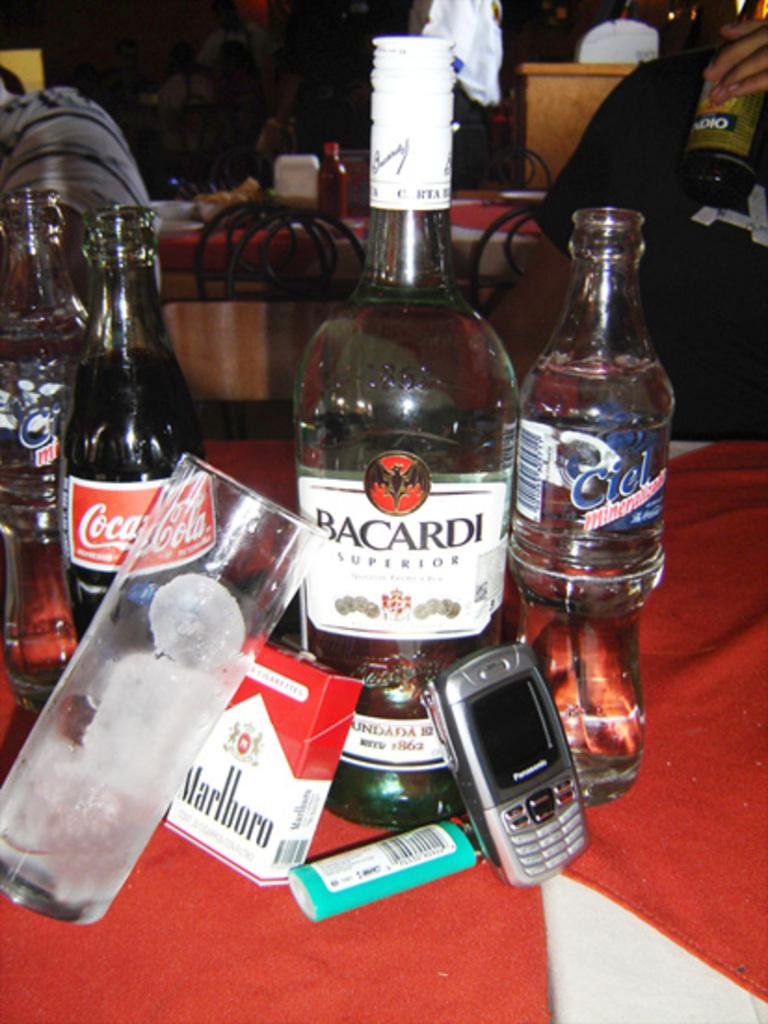<image>
Summarize the visual content of the image. A bottle of bacardi branded alcohol with marlboro branded smokes. 